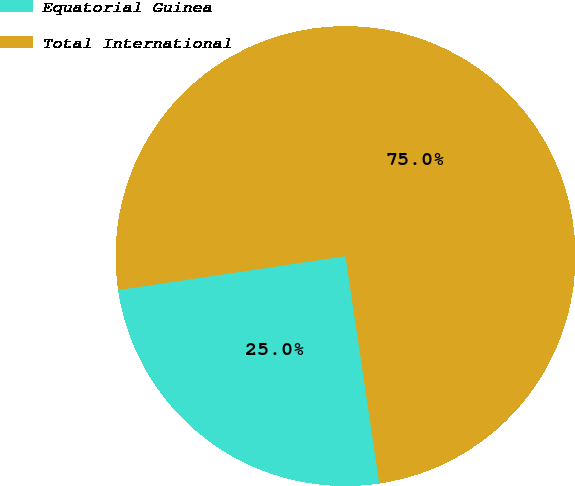Convert chart to OTSL. <chart><loc_0><loc_0><loc_500><loc_500><pie_chart><fcel>Equatorial Guinea<fcel>Total International<nl><fcel>25.0%<fcel>75.0%<nl></chart> 